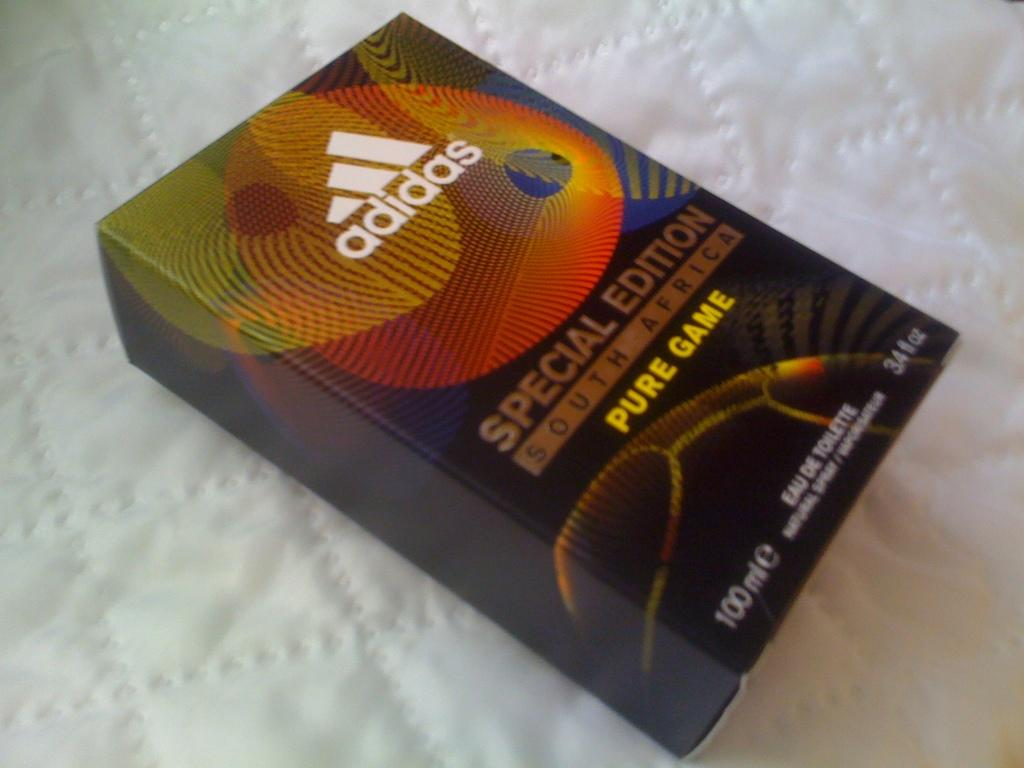<image>
Summarize the visual content of the image. Adidas special edition south african pure game book 